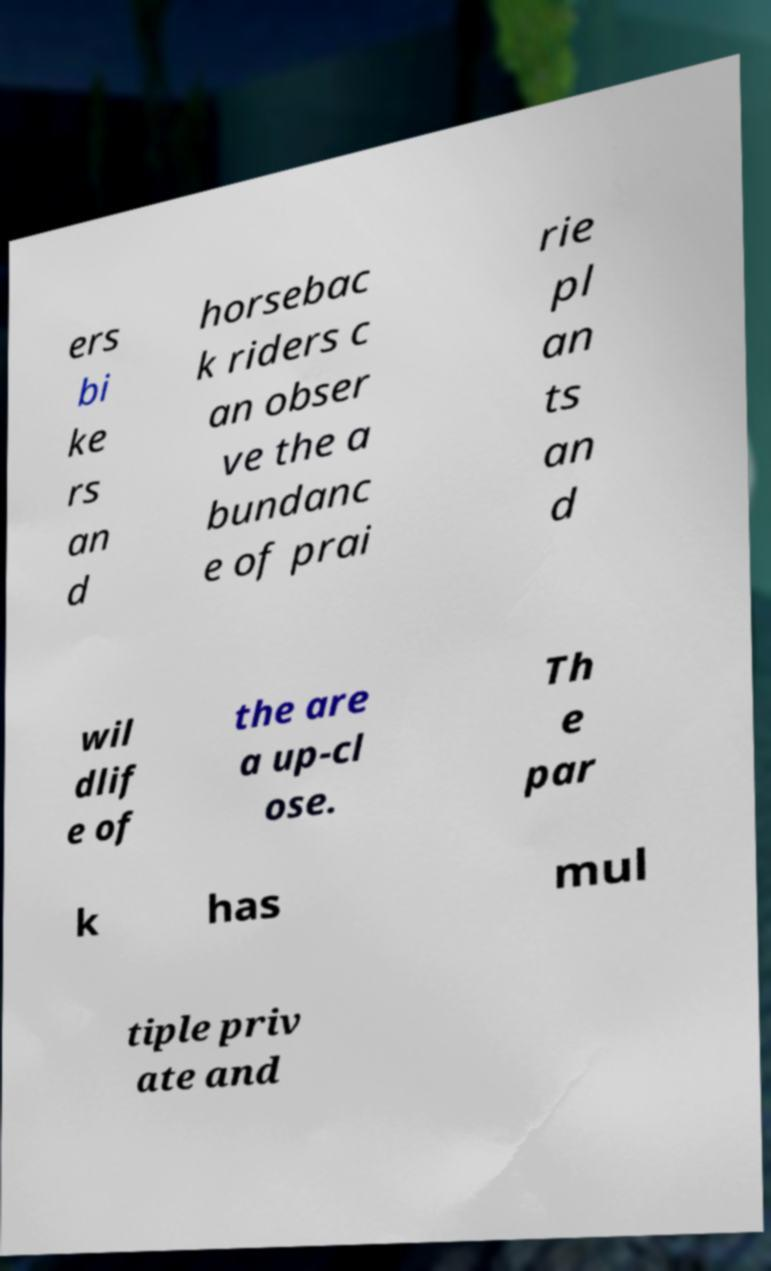What messages or text are displayed in this image? I need them in a readable, typed format. ers bi ke rs an d horsebac k riders c an obser ve the a bundanc e of prai rie pl an ts an d wil dlif e of the are a up-cl ose. Th e par k has mul tiple priv ate and 